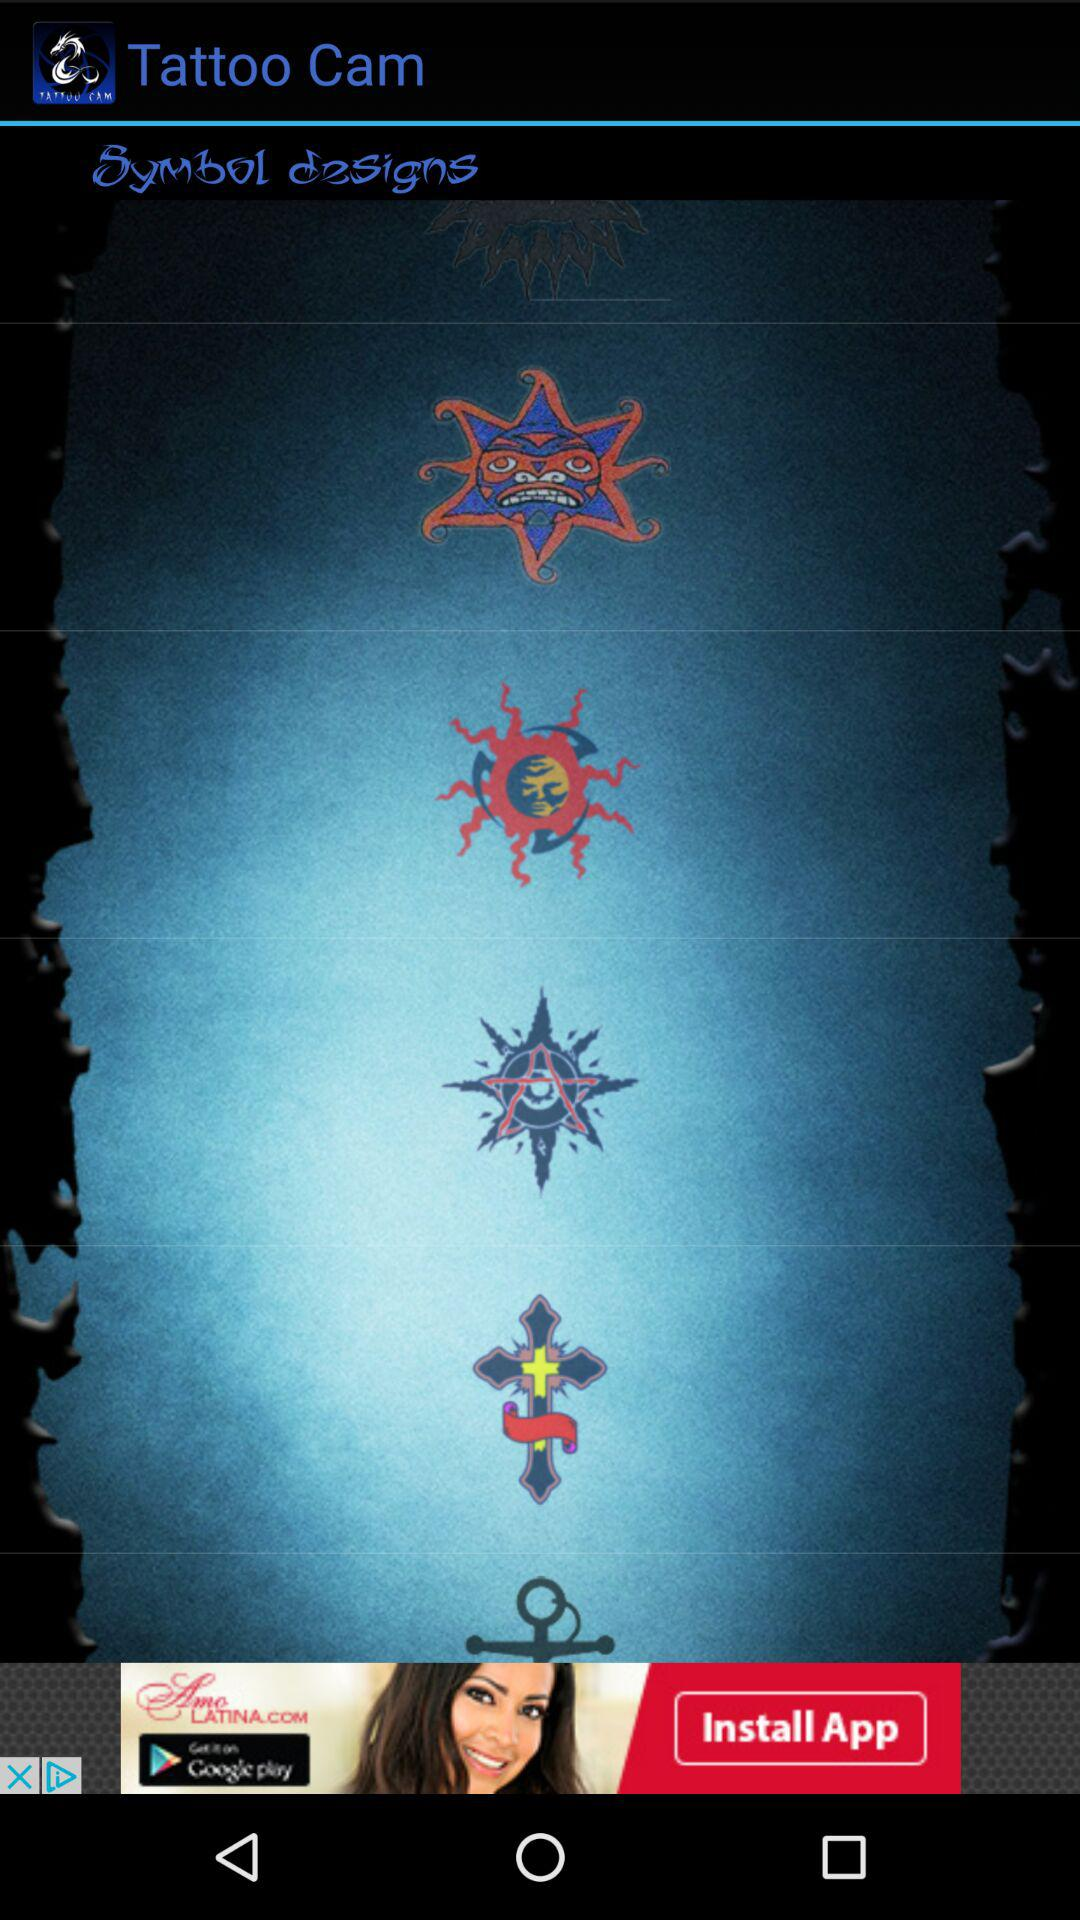What is the application name? The application name is "Tattoo Cam". 